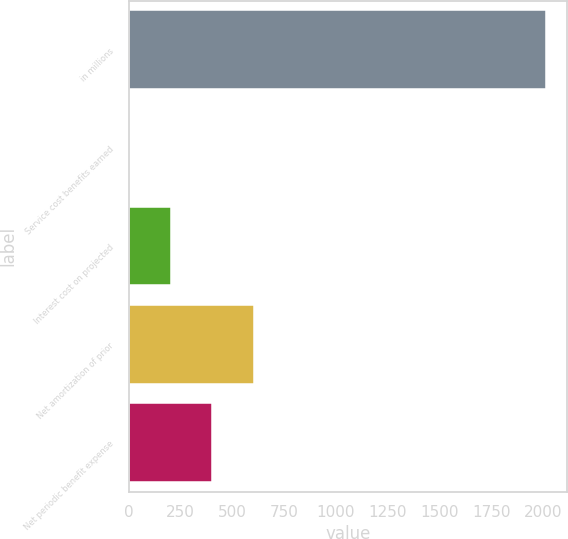Convert chart. <chart><loc_0><loc_0><loc_500><loc_500><bar_chart><fcel>in millions<fcel>Service cost benefits earned<fcel>Interest cost on projected<fcel>Net amortization of prior<fcel>Net periodic benefit expense<nl><fcel>2016<fcel>1<fcel>202.5<fcel>605.5<fcel>404<nl></chart> 